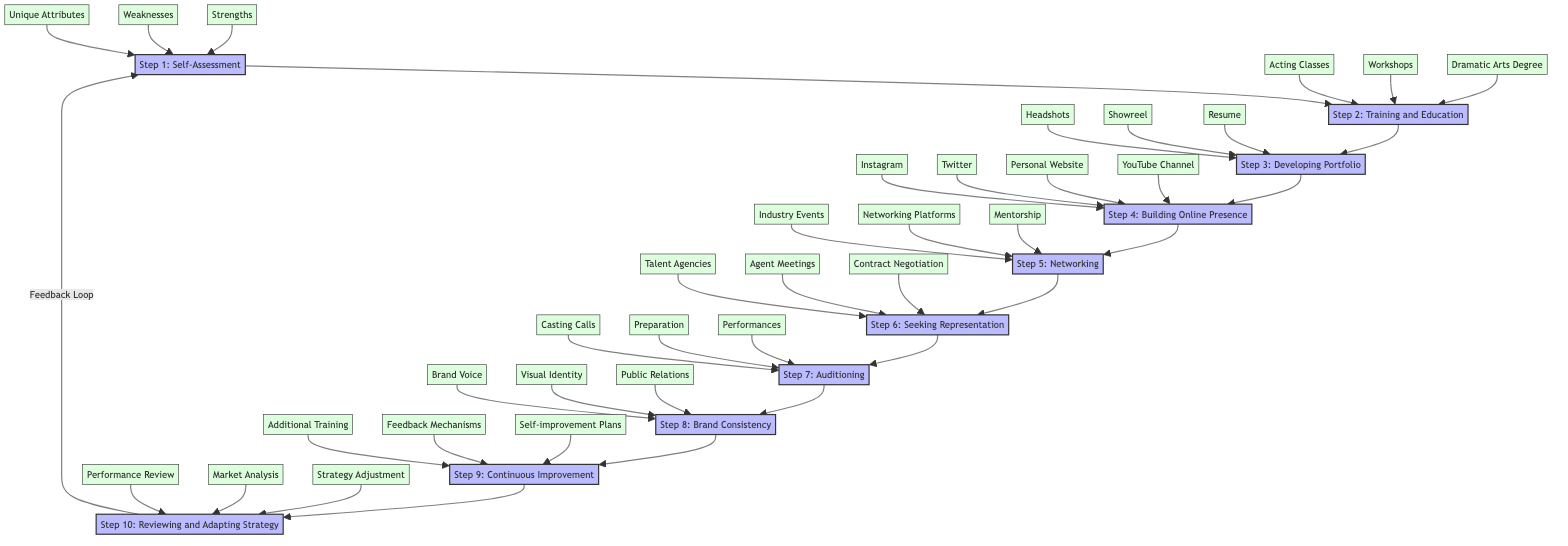What is the first step in developing a personal brand as an aspiring actress? The first step in the flow chart is labeled "Step 1: Self-Assessment," which indicates that evaluating personal strengths, weaknesses, and unique attributes is essential.
Answer: Step 1: Self-Assessment How many steps are there in the process of developing a personal brand? By counting the nodes in the chart, there are a total of 10 steps representing the sequential process of building a personal brand.
Answer: 10 What follows "Seeking Representation" in the flow chart? The flow chart shows that after "Seeking Representation," the next step is "Auditioning," indicating that once you find representation, you should actively participate in auditions.
Answer: Auditioning What are the three keys associated with "Building Online Presence"? The keys connected to the "Building Online Presence" step are "Instagram," "Twitter," "Personal Website," and "YouTube Channel," which highlight the platforms to establish an online presence.
Answer: Instagram, Twitter, Personal Website, YouTube Channel Which step involves maintaining a consistent personal brand? "Step 8: Brand Consistency" is the part of the process focused on ensuring a coherent personal brand across various platforms and interactions.
Answer: Step 8: Brand Consistency What is the purpose of "Continuous Improvement" in the diagram? The "Continuous Improvement" step emphasizes ongoing skill development through additional training, feedback mechanisms, and self-improvement plans. This suggests that actors should always strive to enhance their craft.
Answer: Continuous Improvement Which step involves attending events and connecting with professionals? The step associated with attending industry events and establishing connections is "Step 5: Networking." This implies that networking is critical for building relationships in the acting industry.
Answer: Step 5: Networking What do you need to assess in "Self-Assessment"? The components to evaluate during "Self-Assessment" include "Strengths," "Weaknesses," and "Unique Attributes," which are crucial for understanding oneself as an aspiring actress.
Answer: Strengths, Weaknesses, Unique Attributes How does the flow of the diagram indicate the importance of feedback? The flow chart shows a feedback loop that connects back to "Self-Assessment" after the "Reviewing and Adapting Strategy" step. This suggests that ongoing feedback is vital for refining and enhancing one's personal brand.
Answer: Feedback Loop 